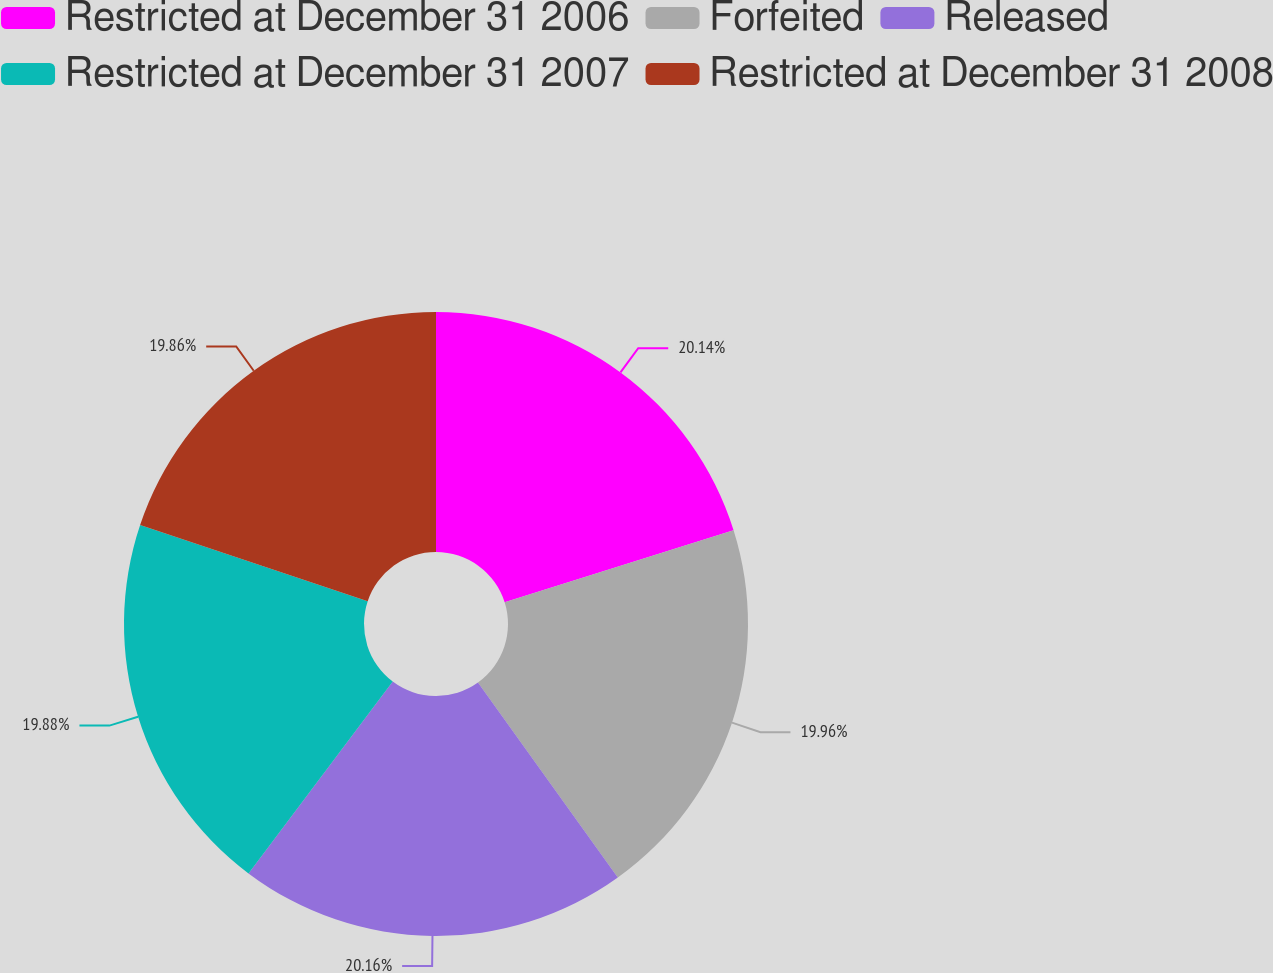Convert chart. <chart><loc_0><loc_0><loc_500><loc_500><pie_chart><fcel>Restricted at December 31 2006<fcel>Forfeited<fcel>Released<fcel>Restricted at December 31 2007<fcel>Restricted at December 31 2008<nl><fcel>20.14%<fcel>19.96%<fcel>20.16%<fcel>19.88%<fcel>19.86%<nl></chart> 